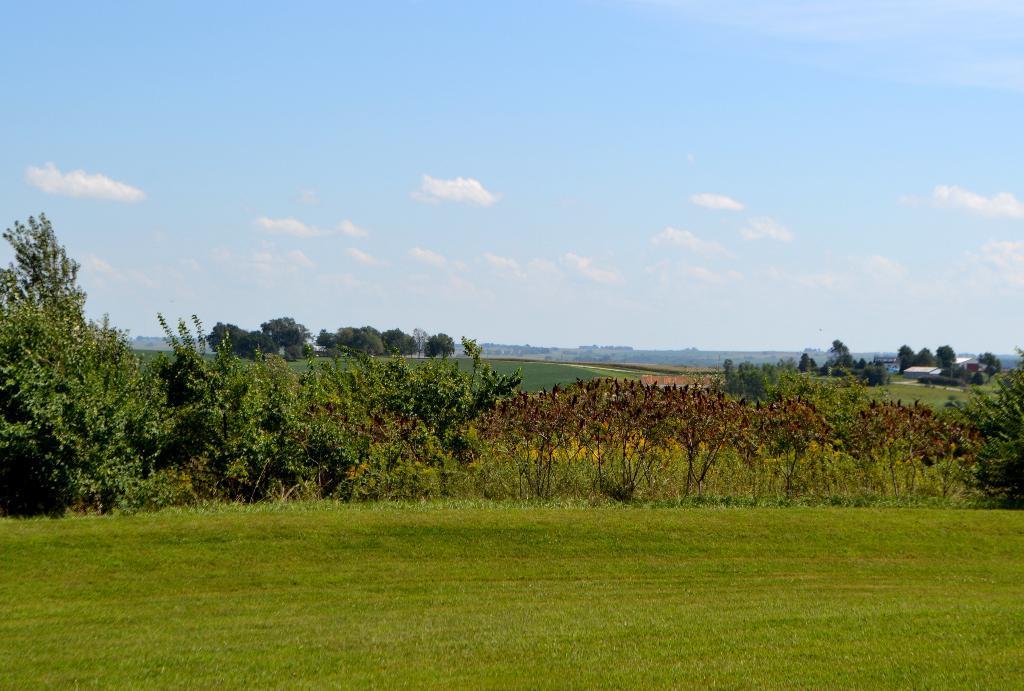Describe this image in one or two sentences. In this image there are trees, grass, a building, mountains and the sky. 